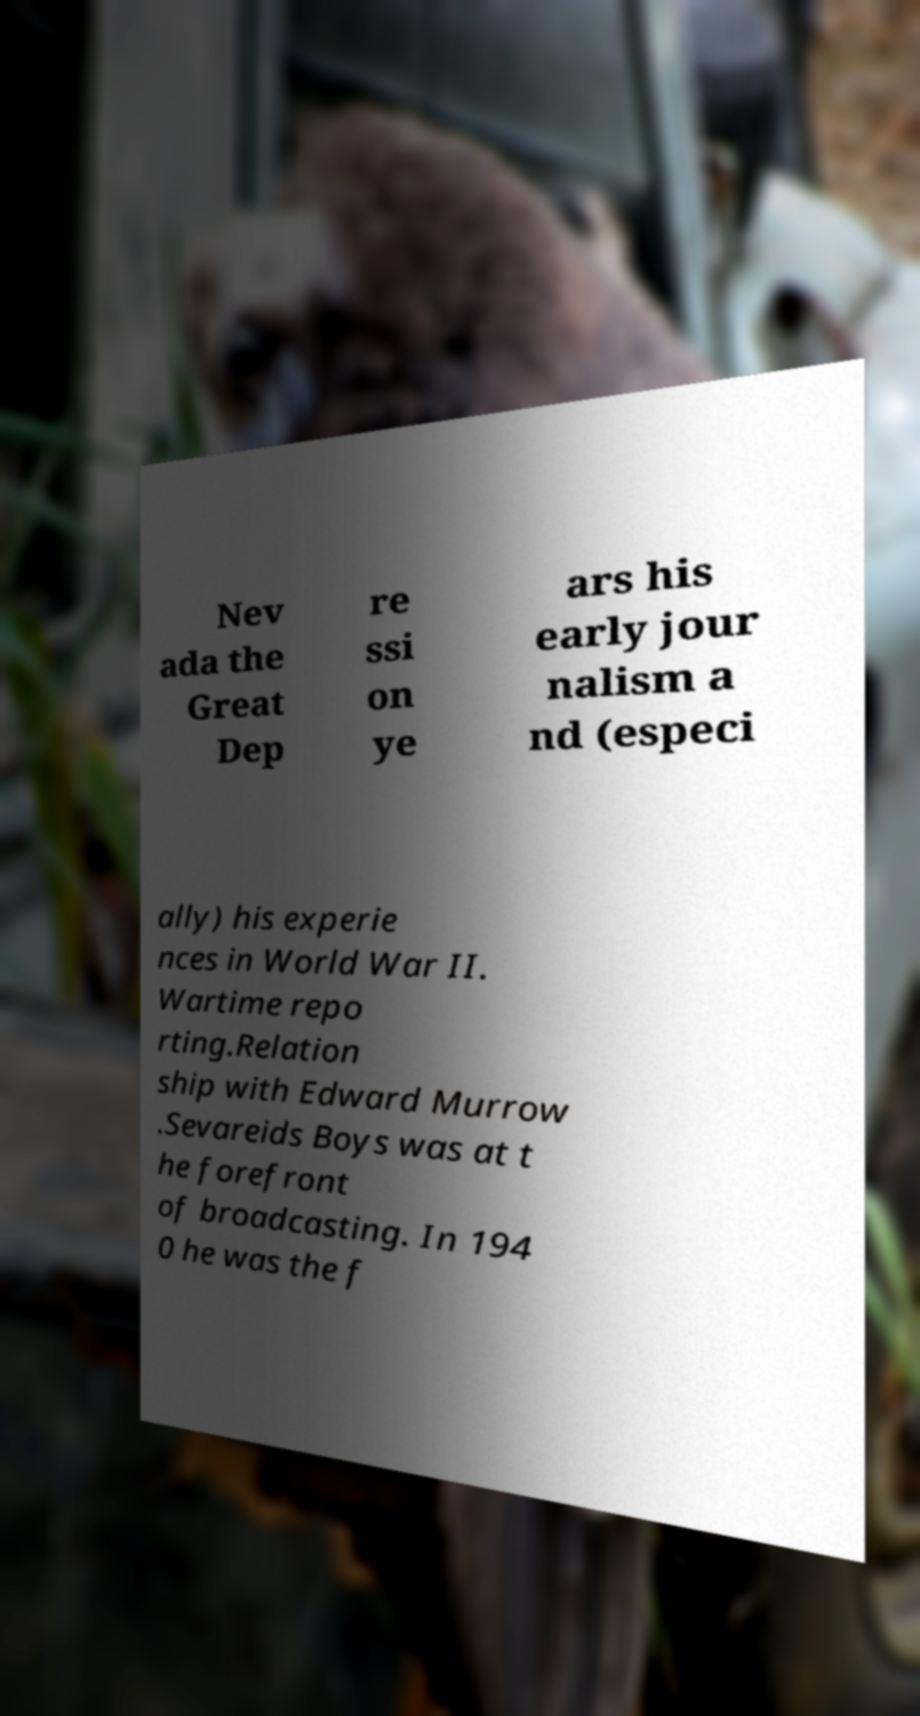Can you accurately transcribe the text from the provided image for me? Nev ada the Great Dep re ssi on ye ars his early jour nalism a nd (especi ally) his experie nces in World War II. Wartime repo rting.Relation ship with Edward Murrow .Sevareids Boys was at t he forefront of broadcasting. In 194 0 he was the f 